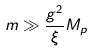Convert formula to latex. <formula><loc_0><loc_0><loc_500><loc_500>m \gg \frac { g ^ { 2 } } { \xi } M _ { p }</formula> 